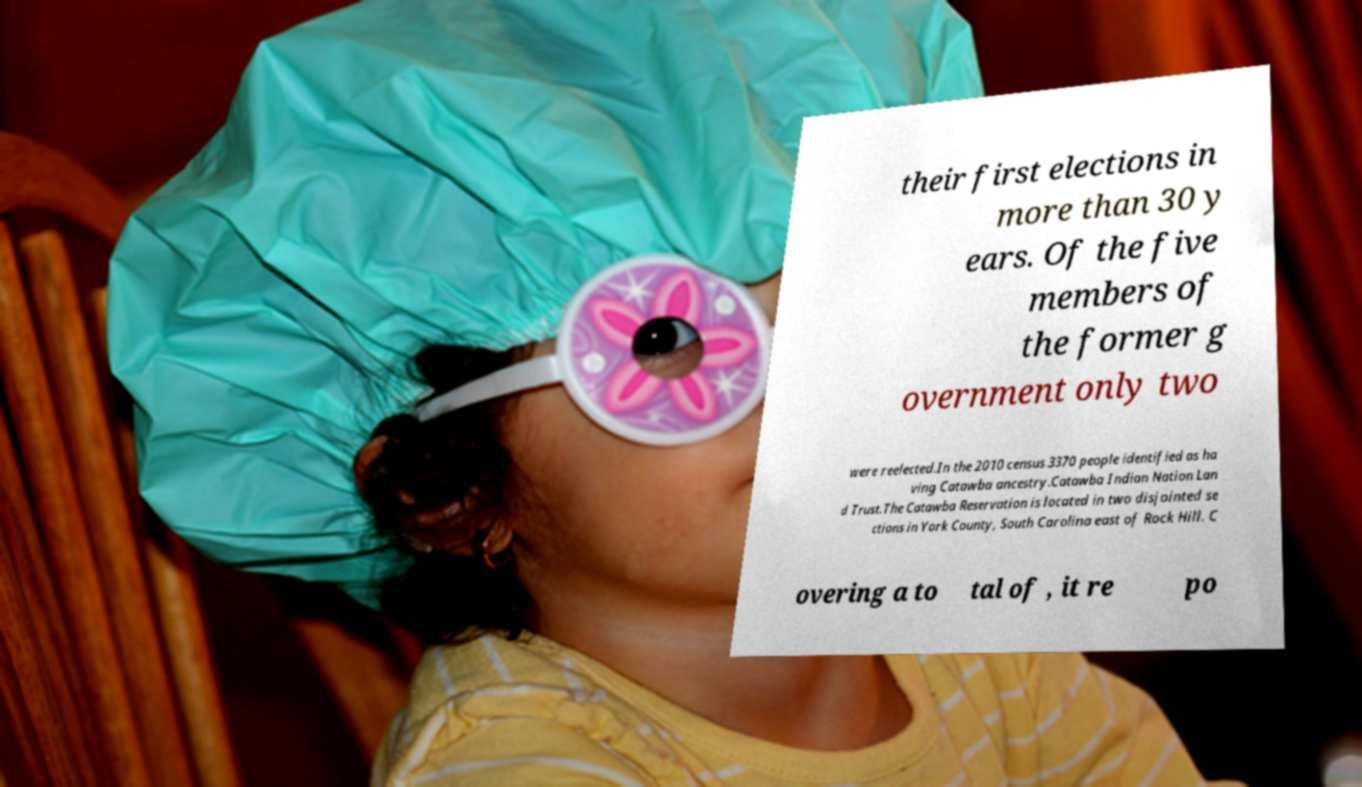For documentation purposes, I need the text within this image transcribed. Could you provide that? their first elections in more than 30 y ears. Of the five members of the former g overnment only two were reelected.In the 2010 census 3370 people identified as ha ving Catawba ancestry.Catawba Indian Nation Lan d Trust.The Catawba Reservation is located in two disjointed se ctions in York County, South Carolina east of Rock Hill. C overing a to tal of , it re po 